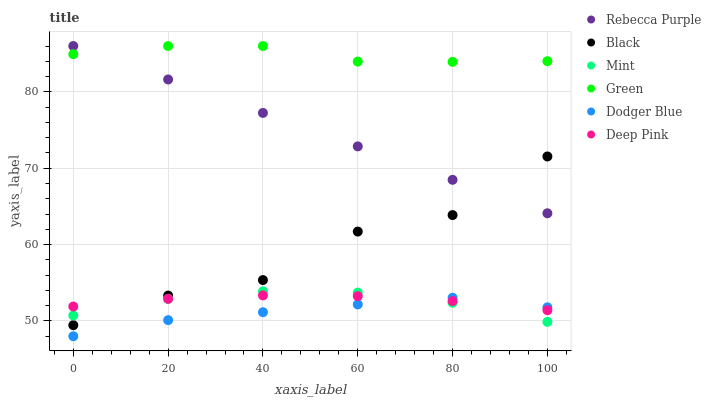Does Dodger Blue have the minimum area under the curve?
Answer yes or no. Yes. Does Green have the maximum area under the curve?
Answer yes or no. Yes. Does Green have the minimum area under the curve?
Answer yes or no. No. Does Dodger Blue have the maximum area under the curve?
Answer yes or no. No. Is Rebecca Purple the smoothest?
Answer yes or no. Yes. Is Black the roughest?
Answer yes or no. Yes. Is Dodger Blue the smoothest?
Answer yes or no. No. Is Dodger Blue the roughest?
Answer yes or no. No. Does Dodger Blue have the lowest value?
Answer yes or no. Yes. Does Green have the lowest value?
Answer yes or no. No. Does Rebecca Purple have the highest value?
Answer yes or no. Yes. Does Dodger Blue have the highest value?
Answer yes or no. No. Is Mint less than Green?
Answer yes or no. Yes. Is Green greater than Dodger Blue?
Answer yes or no. Yes. Does Black intersect Mint?
Answer yes or no. Yes. Is Black less than Mint?
Answer yes or no. No. Is Black greater than Mint?
Answer yes or no. No. Does Mint intersect Green?
Answer yes or no. No. 